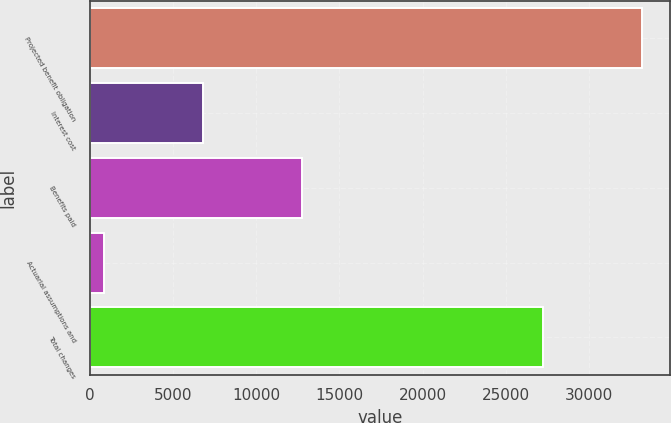Convert chart. <chart><loc_0><loc_0><loc_500><loc_500><bar_chart><fcel>Projected benefit obligation<fcel>Interest cost<fcel>Benefits paid<fcel>Actuarial assumptions and<fcel>Total changes<nl><fcel>33215.8<fcel>6830.8<fcel>12786.6<fcel>875<fcel>27260<nl></chart> 